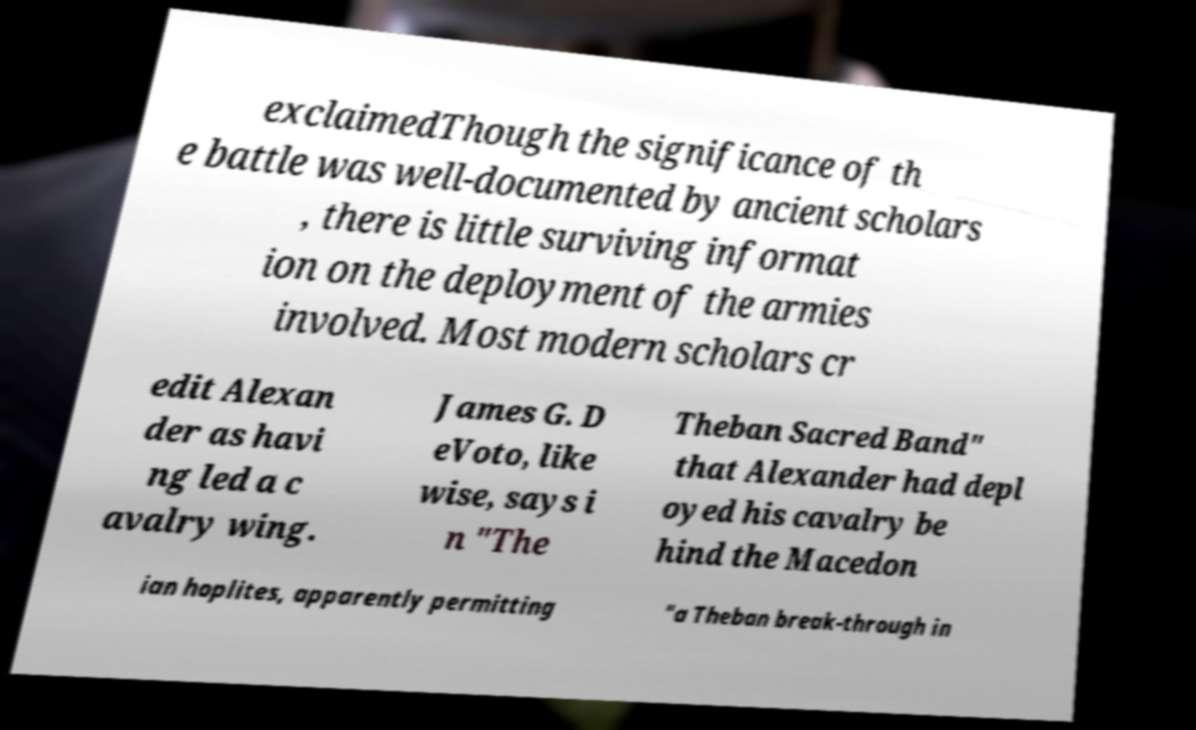For documentation purposes, I need the text within this image transcribed. Could you provide that? exclaimedThough the significance of th e battle was well-documented by ancient scholars , there is little surviving informat ion on the deployment of the armies involved. Most modern scholars cr edit Alexan der as havi ng led a c avalry wing. James G. D eVoto, like wise, says i n "The Theban Sacred Band" that Alexander had depl oyed his cavalry be hind the Macedon ian hoplites, apparently permitting "a Theban break-through in 